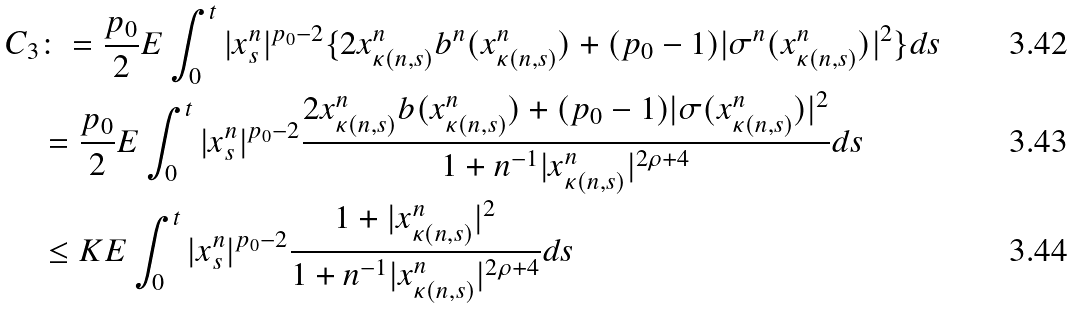Convert formula to latex. <formula><loc_0><loc_0><loc_500><loc_500>C _ { 3 } & \colon = \frac { p _ { 0 } } { 2 } E \int _ { 0 } ^ { t } | x _ { s } ^ { n } | ^ { p _ { 0 } - 2 } \{ 2 x _ { \kappa ( n , s ) } ^ { n } b ^ { n } ( x _ { \kappa ( n , s ) } ^ { n } ) + ( p _ { 0 } - 1 ) | \sigma ^ { n } ( x _ { \kappa ( n , s ) } ^ { n } ) | ^ { 2 } \} d s \\ & = \frac { p _ { 0 } } { 2 } E \int _ { 0 } ^ { t } | x _ { s } ^ { n } | ^ { p _ { 0 } - 2 } \frac { 2 x _ { \kappa ( n , s ) } ^ { n } b ( x _ { \kappa ( n , s ) } ^ { n } ) + ( p _ { 0 } - 1 ) | \sigma ( x _ { \kappa ( n , s ) } ^ { n } ) | ^ { 2 } } { 1 + n ^ { - 1 } | x _ { \kappa ( n , s ) } ^ { n } | ^ { 2 \rho + 4 } } d s \\ & \leq K E \int _ { 0 } ^ { t } | x _ { s } ^ { n } | ^ { p _ { 0 } - 2 } \frac { 1 + | x _ { \kappa ( n , s ) } ^ { n } | ^ { 2 } } { 1 + n ^ { - 1 } | x _ { \kappa ( n , s ) } ^ { n } | ^ { 2 \rho + 4 } } d s</formula> 